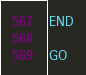Convert code to text. <code><loc_0><loc_0><loc_500><loc_500><_SQL_>END

GO

</code> 